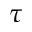Convert formula to latex. <formula><loc_0><loc_0><loc_500><loc_500>\tau</formula> 